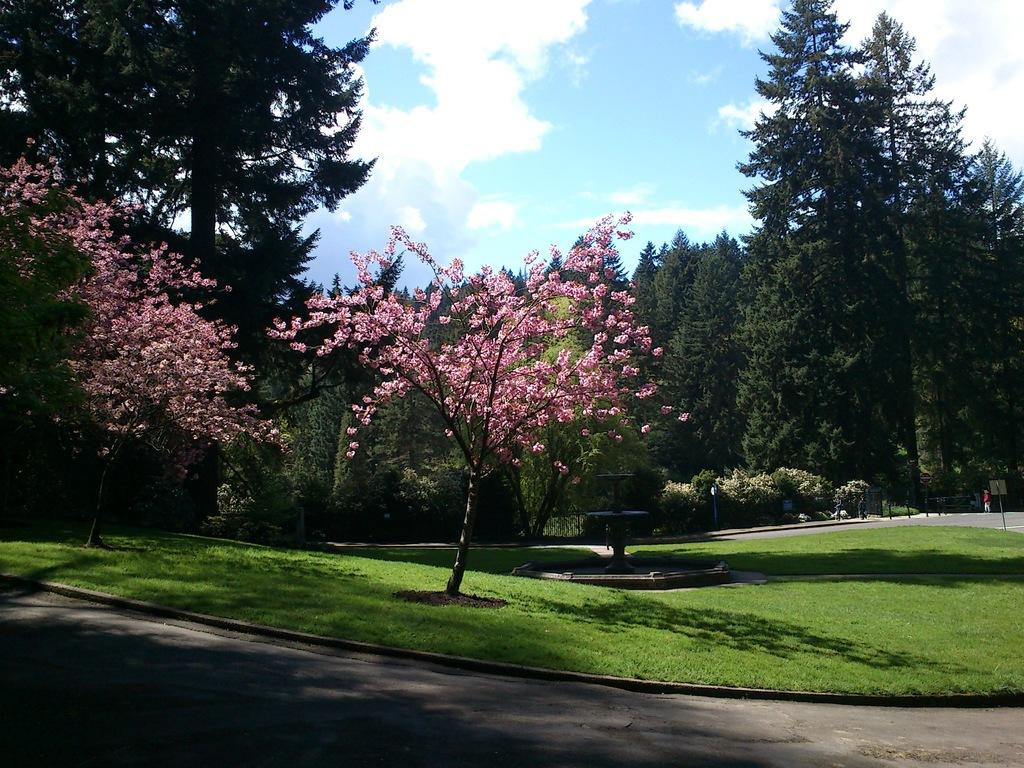What type of pathway is shown in the image? There is a road in the image. What can be seen on the ground in the image? The ground with grass is visible in the image. What type of vegetation is present in the image? There are trees in the image. What are the tall, vertical structures in the image? There are poles in the image. What is visible above the ground in the image? The sky is visible in the image. What can be observed in the sky in the image? Clouds are present in the sky. Who is the expert on respect in the image? There is no indication of an expert on respect in the image. What type of space is depicted in the image? The image does not depict any specific space; it shows a road, ground, trees, poles, and sky. 